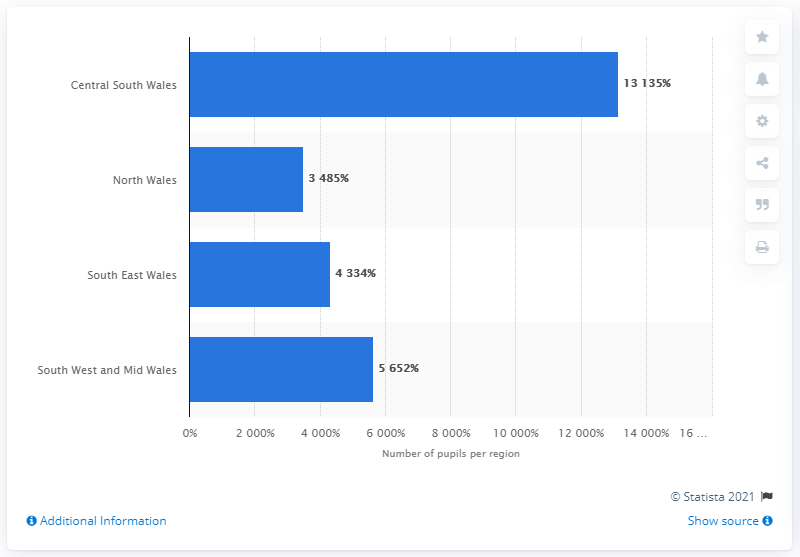Highlight a few significant elements in this photo. In 2016, Central South Wales was the most linguistically diverse region in Wales. 